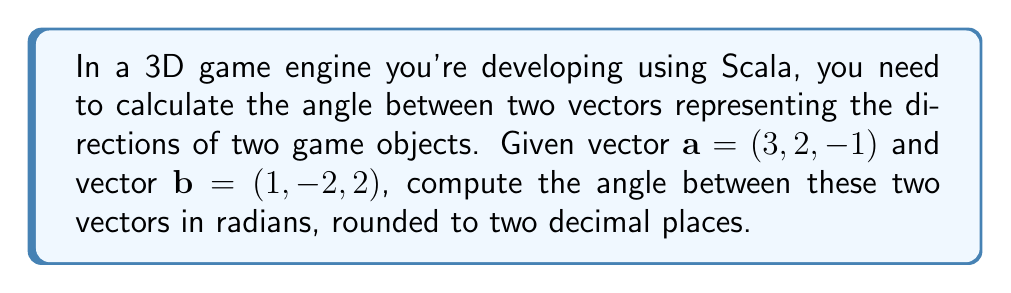Can you answer this question? To find the angle between two vectors in 3D space, we can use the dot product formula:

$$\cos \theta = \frac{\mathbf{a} \cdot \mathbf{b}}{|\mathbf{a}||\mathbf{b}|}$$

Where $\theta$ is the angle between the vectors, $\mathbf{a} \cdot \mathbf{b}$ is the dot product of the vectors, and $|\mathbf{a}|$ and $|\mathbf{b}|$ are the magnitudes of vectors $\mathbf{a}$ and $\mathbf{b}$ respectively.

Step 1: Calculate the dot product $\mathbf{a} \cdot \mathbf{b}$
$$\mathbf{a} \cdot \mathbf{b} = (3)(1) + (2)(-2) + (-1)(2) = 3 - 4 - 2 = -3$$

Step 2: Calculate the magnitudes of the vectors
$$|\mathbf{a}| = \sqrt{3^2 + 2^2 + (-1)^2} = \sqrt{9 + 4 + 1} = \sqrt{14}$$
$$|\mathbf{b}| = \sqrt{1^2 + (-2)^2 + 2^2} = \sqrt{1 + 4 + 4} = 3$$

Step 3: Substitute into the formula
$$\cos \theta = \frac{-3}{\sqrt{14} \cdot 3}$$

Step 4: Calculate $\theta$ using the inverse cosine (arccos) function
$$\theta = \arccos\left(\frac{-3}{\sqrt{14} \cdot 3}\right)$$

Step 5: Evaluate and round to two decimal places
$$\theta \approx 2.00 \text{ radians}$$
Answer: 2.00 radians 